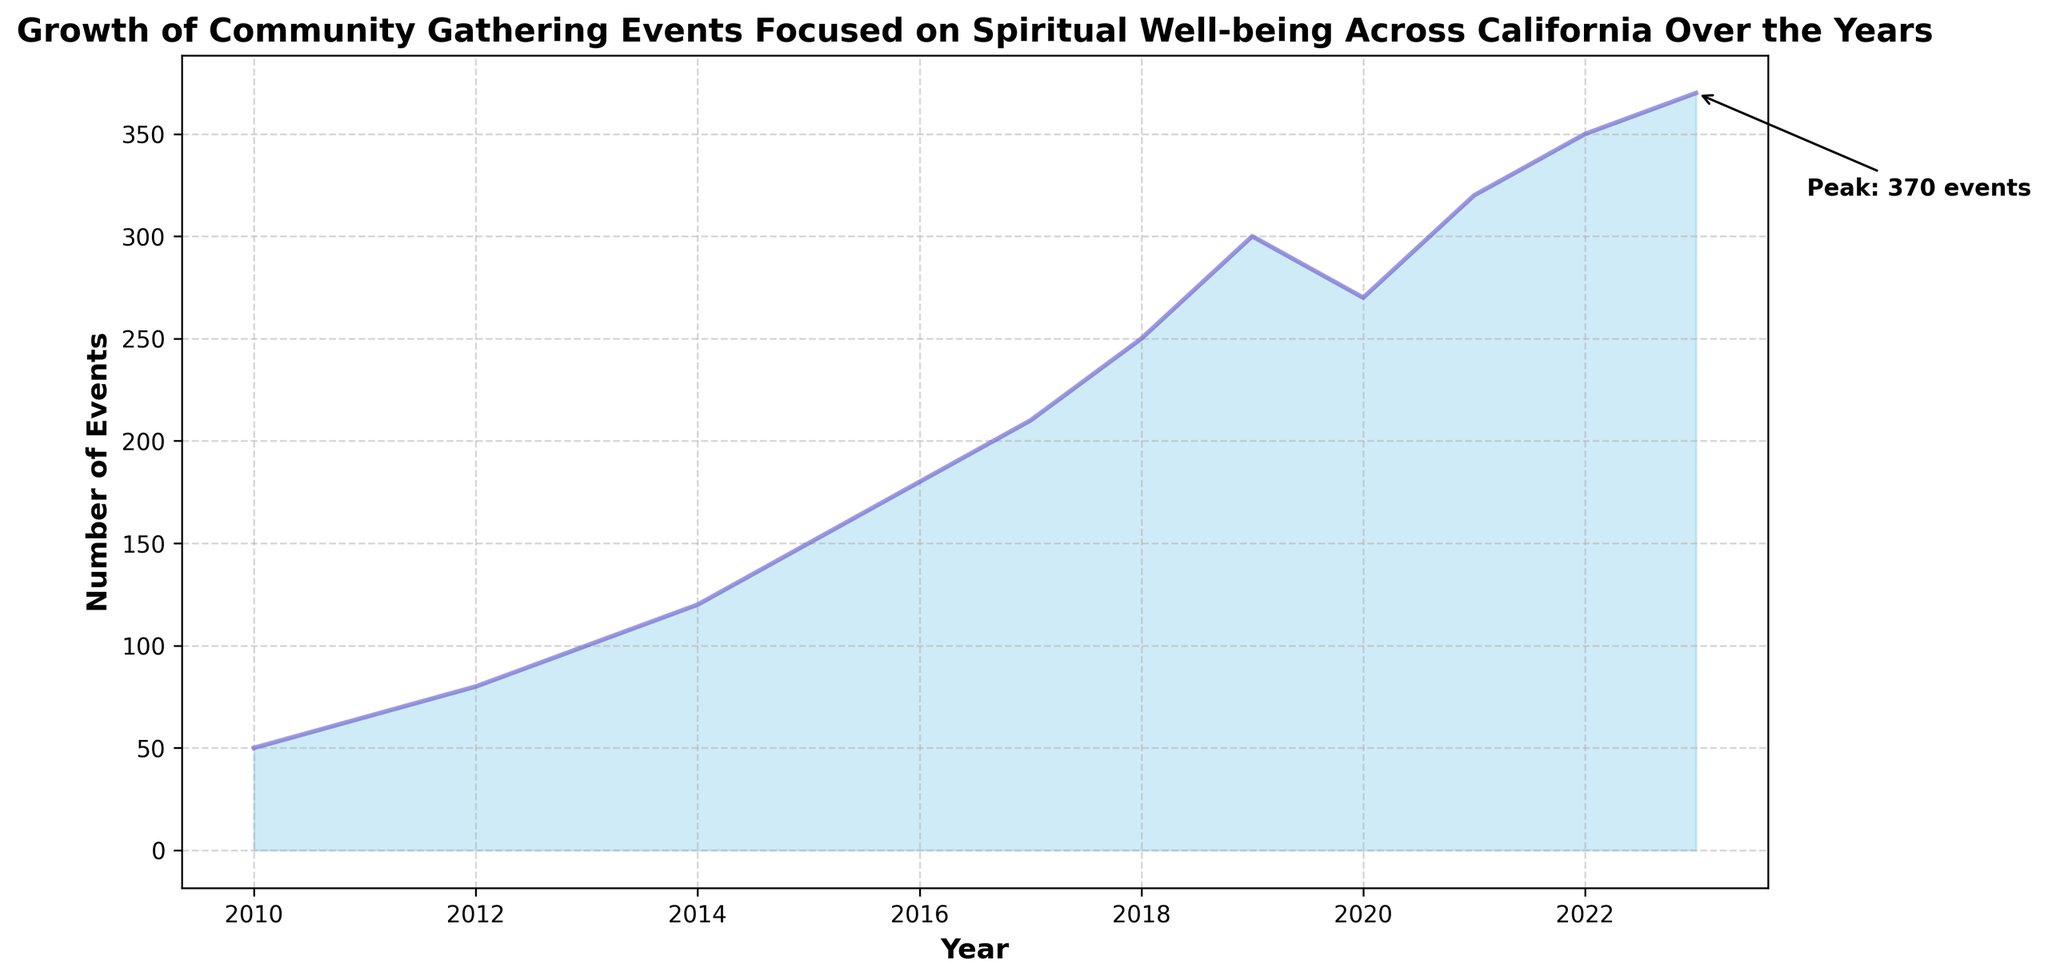What is the maximum number of events recorded in a single year? The maximum number of events can be identified from the figure where the highest point on the area chart is marked. In this case, it's indicated by the annotation as "Peak: 370 events."
Answer: 370 Which year saw a decline in the number of events compared to the previous year? Looking at the area chart, there’s a visible decrease in the number of events in 2020 compared to 2019.
Answer: 2020 What is the average number of events from 2010 to 2015? Sum the number of events for each year between 2010 and 2015 (50 + 65 + 80 + 100 + 120 + 150) and divide by the number of years, which is 6. The calculation is (50 + 65 + 80 + 100 + 120 + 150) / 6.
Answer: 94.17 In which year did the number of events first exceed 250? Find the year where the number of events surpasses 250 by looking at the area chart. The first time this happens is in 2018.
Answer: 2018 How did the number of events in 2011 compare to 2010? By looking at the difference in height between 2010 and 2011 on the area chart, it's clear that there were more events in 2011 compared to 2010.
Answer: Higher Which section of the graph (2010-2023) has the steepest increase in the number of events? The steepest part of the graph indicates the largest increase over a short period. Observing the chart, the section from 2017 to 2019 shows a steep increase.
Answer: 2017-2019 What is the total number of events from 2010 to 2023? Add the number of events for each year from 2010 to 2023 to find the total. The calculation is 50 + 65 + 80 + 100 + 120 + 150 + 180 + 210 + 250 + 300 + 270 + 320 + 350 + 370.
Answer: 2815 Did the number of events plateau at any point from 2010 to 2023? By analyzing the trend of the graph, the number of events does not seem to plateau at any point but continues to rise, except for the slight decline in 2020.
Answer: No 